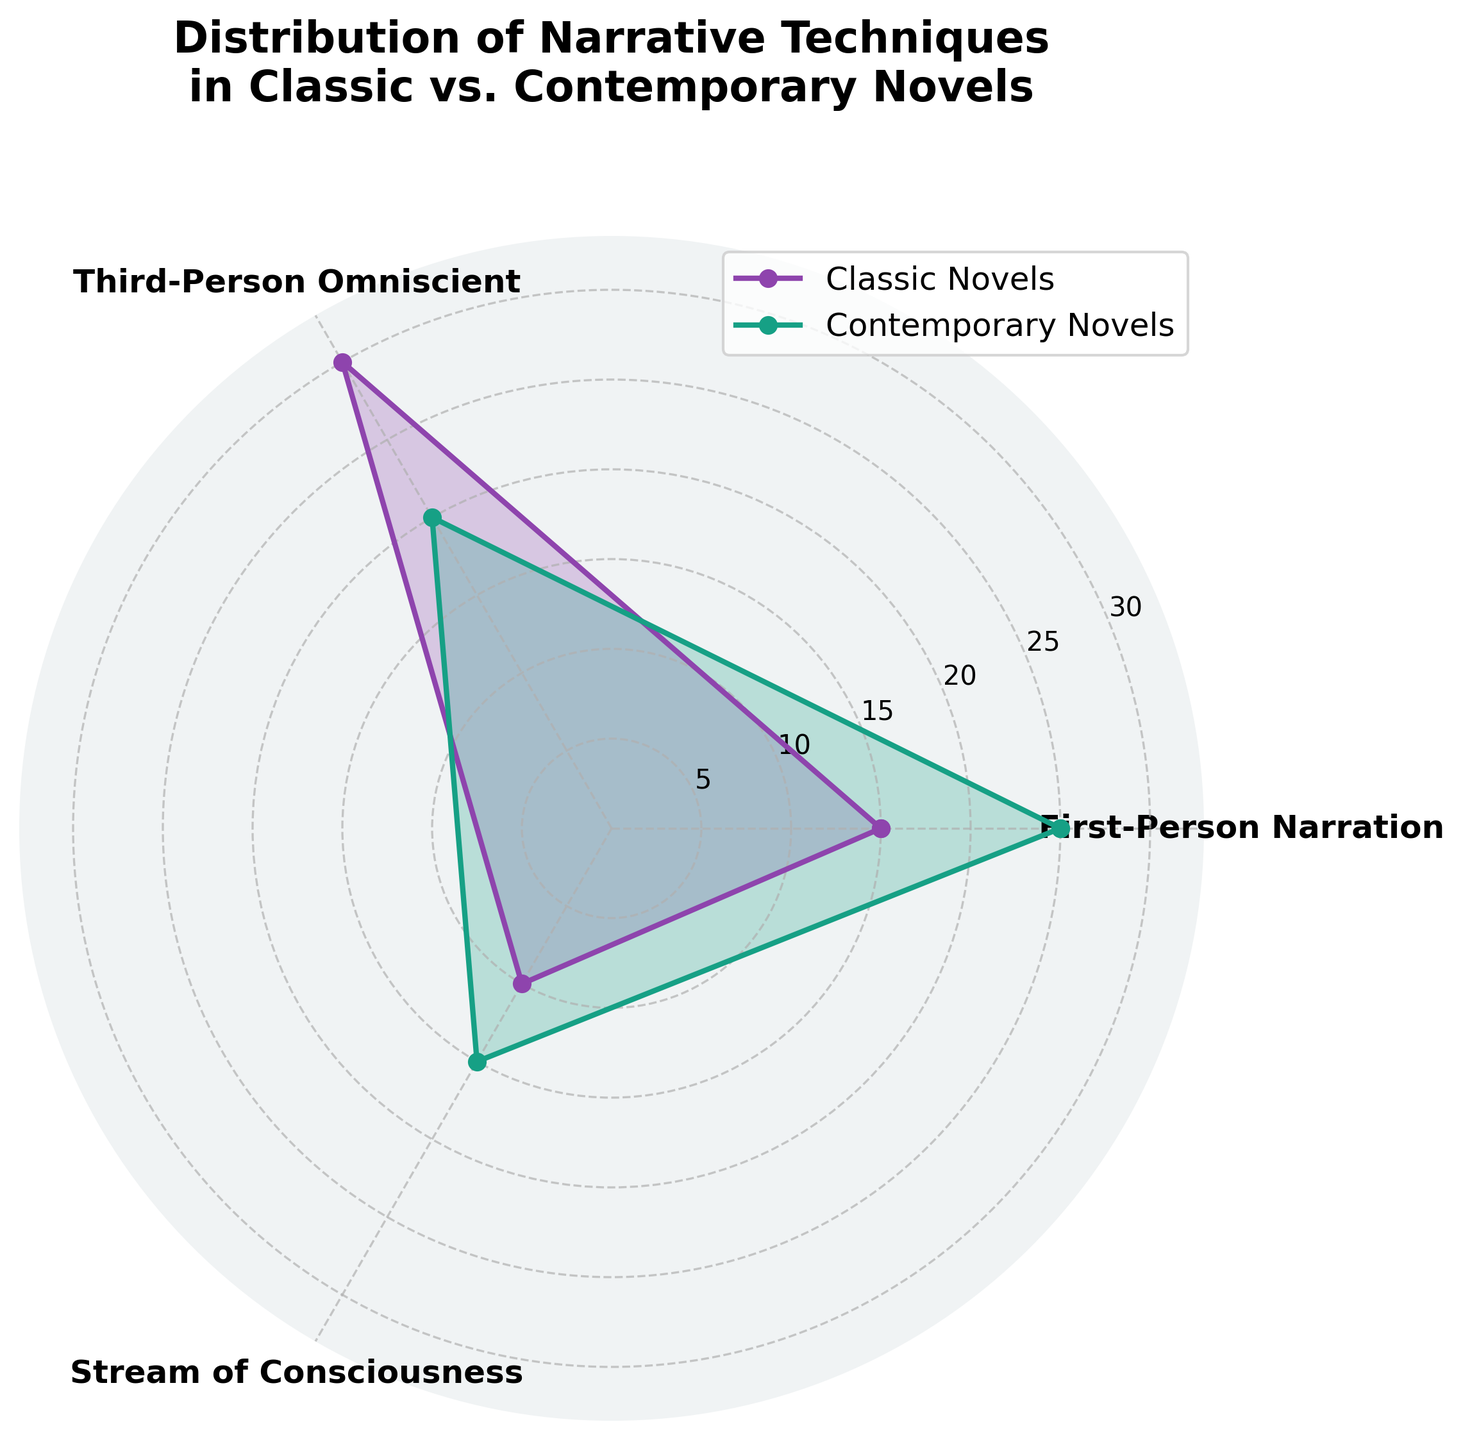What are the narrative techniques shown in the rose chart? The rose chart displays three narrative techniques on the axes. We can identify these techniques from the labels in the plot.
Answer: First-Person Narration, Third-Person Omniscient, Stream of Consciousness Which narrative technique is used most frequently in contemporary novels? By examining the filled areas and the data points on the contemporary (green) plot, the largest data point reaches near the outer edge for the specified techniques.
Answer: First-Person Narration Among the techniques shown, which one shows a greater frequency in classic novels compared to contemporary novels? To determine this, we compare the filled areas of the classic (purple) and contemporary (green) plots for each of the three techniques. The one where the classic plot extends further represents the greater frequency.
Answer: Third-Person Omniscient How does First-Person Narration compare between classic and contemporary novels? We need to compare the purple and green data points on the First-Person Narration axis. The green plot extends further out than the purple one, indicating a higher frequency.
Answer: Contemporary novels use it more frequently Calculate the total usage of the three narrative techniques in classic novels shown in the rose chart. Sum the data points for the three techniques in classic novels: 15 (First-Person Narration) + 30 (Third-Person Omniscient) + 10 (Stream of Consciousness).
Answer: 55 Which technique has the smallest difference in usage between classic and contemporary novels? Calculate the difference between classic and contemporary usage for each technique and identify the smallest: First-Person Narration (25 - 15 = 10), Third-Person Omniscient (30 - 20 = 10), Stream of Consciousness (15 - 10 = 5).
Answer: Stream of Consciousness How do the total frequencies of these three narrative techniques compare between classic and contemporary novels? Sum the frequencies for classic novels: 15 + 30 + 10 = 55. Sum the frequencies for contemporary novels: 25 + 20 + 15 = 60. Compare the two sums.
Answer: Contemporary novels use them more frequently What is the angle between each narrative technique in the rose chart? Since there are three techniques equally spaced around the rose chart, we divide the full circle (360 degrees or 2π radians) by the number of techniques (3): 360/3 = 120 degrees.
Answer: 120 degrees 